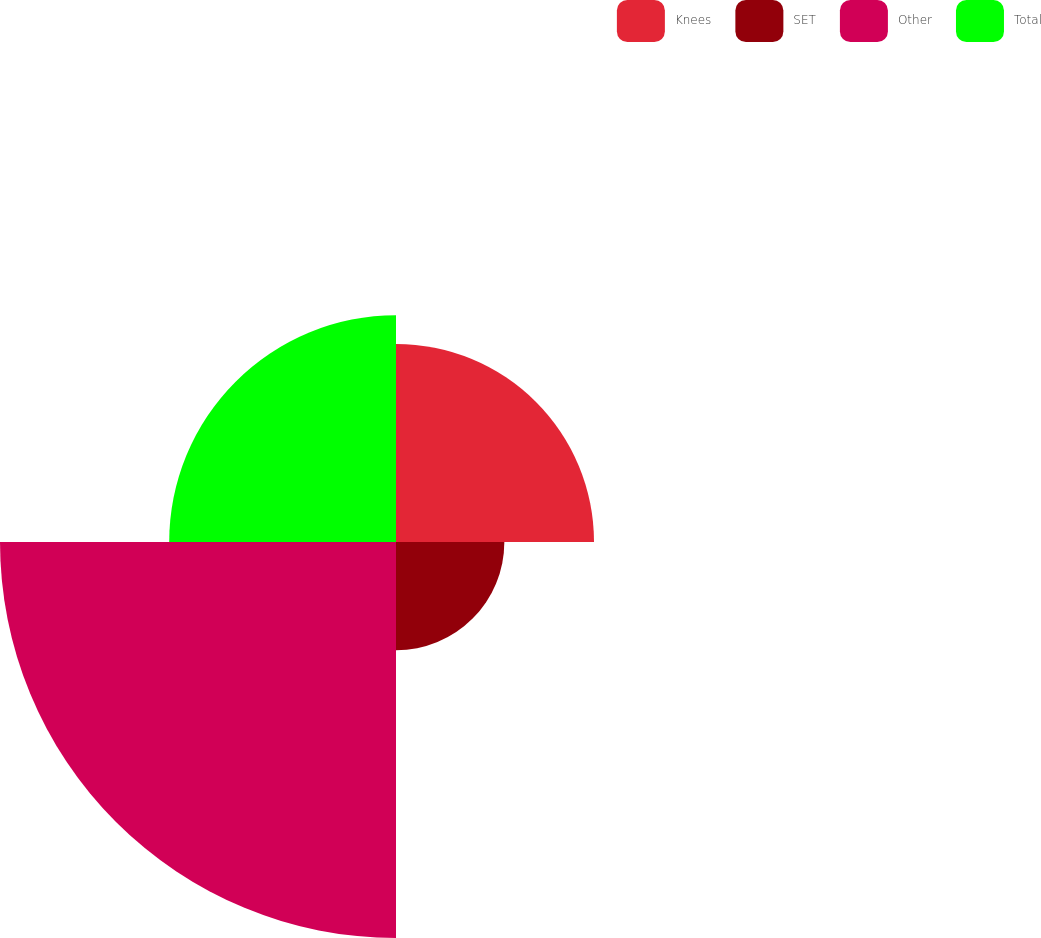<chart> <loc_0><loc_0><loc_500><loc_500><pie_chart><fcel>Knees<fcel>SET<fcel>Other<fcel>Total<nl><fcel>21.31%<fcel>11.66%<fcel>42.62%<fcel>24.41%<nl></chart> 